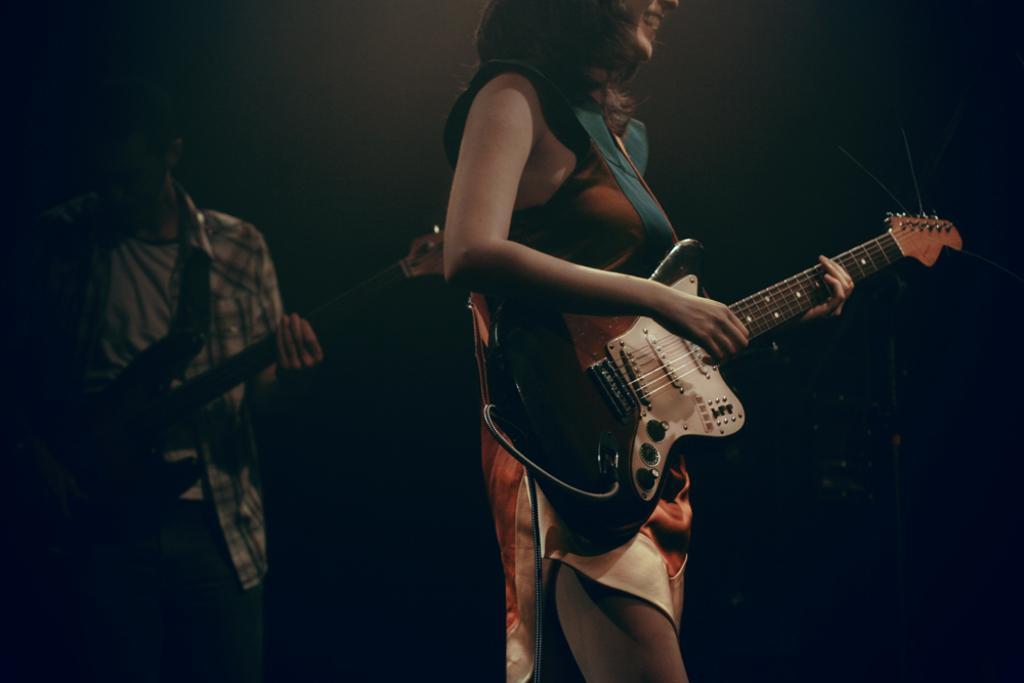In one or two sentences, can you explain what this image depicts? There is a woman standing at the center. She is holding a guitar in her hand and she is smiling. There is a man standing on left side and he is having holding a guitar in his hand. 